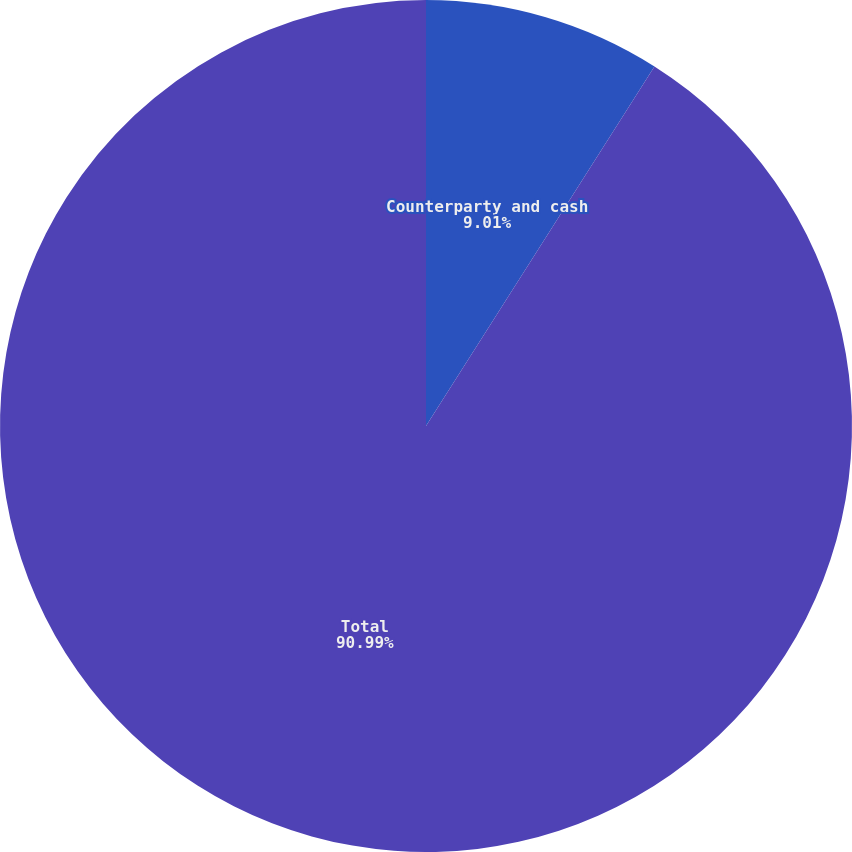Convert chart to OTSL. <chart><loc_0><loc_0><loc_500><loc_500><pie_chart><fcel>Counterparty and cash<fcel>Total<nl><fcel>9.01%<fcel>90.99%<nl></chart> 